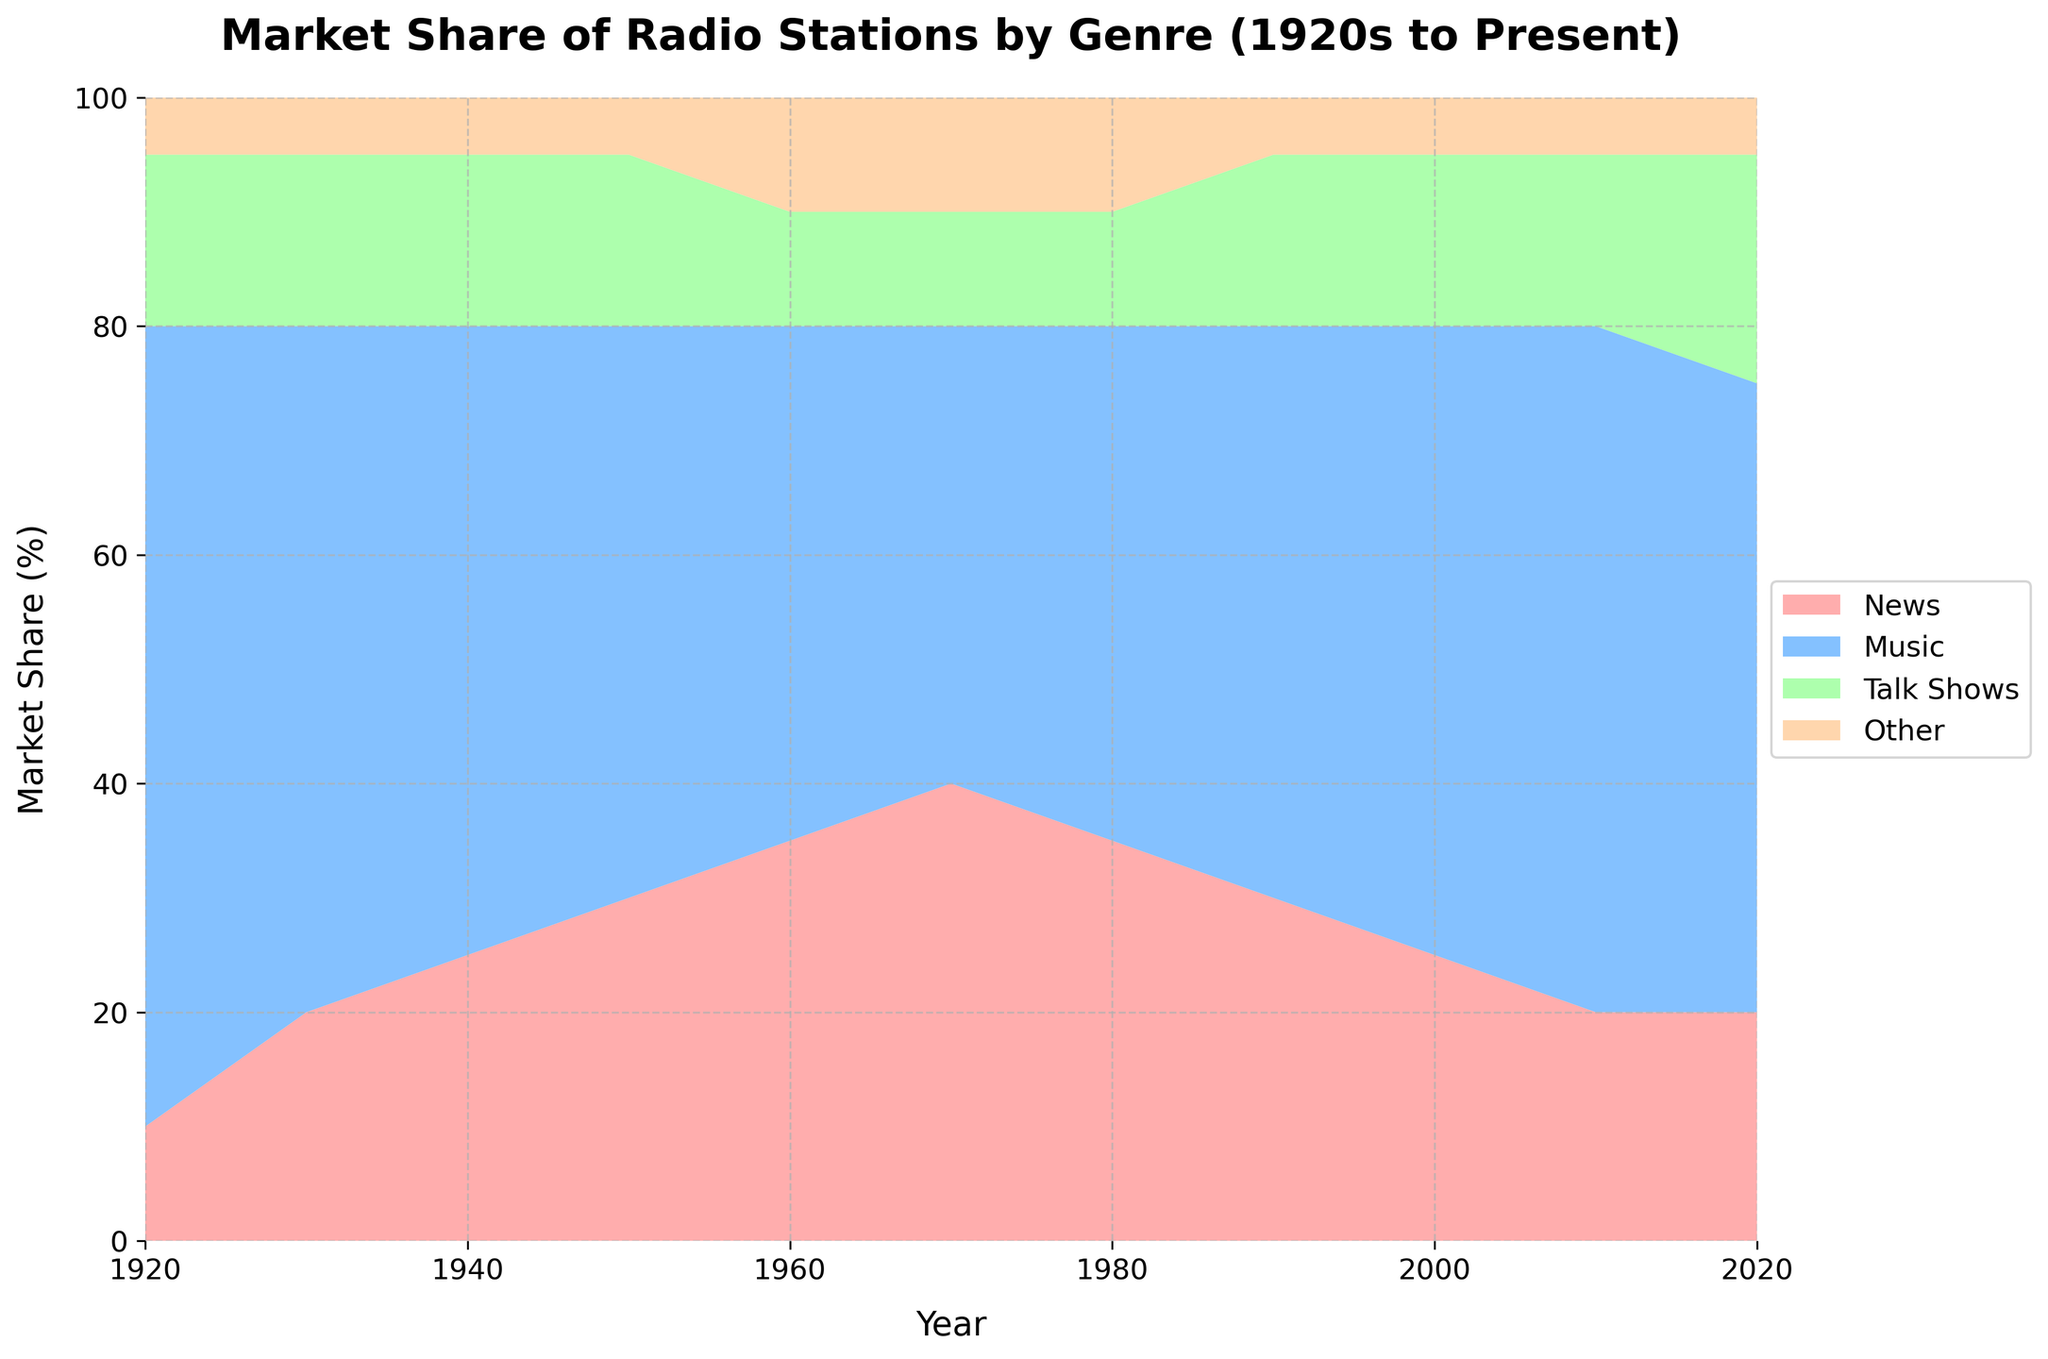What is the title of the figure? The title of the figure typically appears at the top and is designed to give a quick overview of what the figure represents. In this case, it reads, "Market Share of Radio Stations by Genre (1920s to Present)."
Answer: Market Share of Radio Stations by Genre (1920s to Present) How many genres are represented in the figure? The figure's legend, located typically to the side or bottom, lists all the categories being represented. Here, there are four genres: News, Music, Talk Shows, and Other.
Answer: Four Which genre had the highest market share in the 1920s? By looking at the figure around the 1920 point on the x-axis, you can see the thickness of each colored area. The widest area represents Music, indicating it had the largest market share in the 1920s.
Answer: Music How did the market share of News change from 1920 to 1940? To determine this, locate the News area at 1920 and compare its width to 1940. In 1920, News had a 10% share, and by 1940, it had increased to 25%. Subtracting 10% from 25%, the market share of News increased by 15 percentage points.
Answer: Increased by 15 percentage points Which genre experienced the most fluctuation in market share over the entire period? To answer this, observe each genre from 1920 to 2020 and see which has the most variation. Music has significant fluctuations, especially dropping in the mid-20th century and then rising and falling again.
Answer: Music How do the market shares of Talk Shows compare between 1960 and 2020? Look at the width of the Talk Shows area at 1960 and 2020. In 1960, the share is 10%, but in 2020, it increased to 20%. Hence, the Talk Shows share doubled over this period.
Answer: It doubled Between which decades did the genre 'Other' see any noticeable change? Look at the area for 'Other' across decades. There is an increase from 5% in 1950 to 10% in 1960 and consistently maintains at 10% in subsequent years.
Answer: 1950 to 1960 Which genre showed the least change in market share over the years? Examine the stability of each genre's area. The 'Other' genre shows the least change, being quite stable at around 5-10% throughout the years.
Answer: Other In what decade did News achieve its peak market share, and what was its percentage? Identify the widest part of the News area. The peak is around the 1970 mark, with a peak share of 40%.
Answer: 1970, 40% What is the sum of the market shares for Talk Shows and Other genres in 1980? Find the values for Talk Shows and Other in 1980. Talk Shows have 10%, and Other have 10%. Adding these together gives 20%.
Answer: 20% 